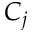<formula> <loc_0><loc_0><loc_500><loc_500>C _ { j }</formula> 